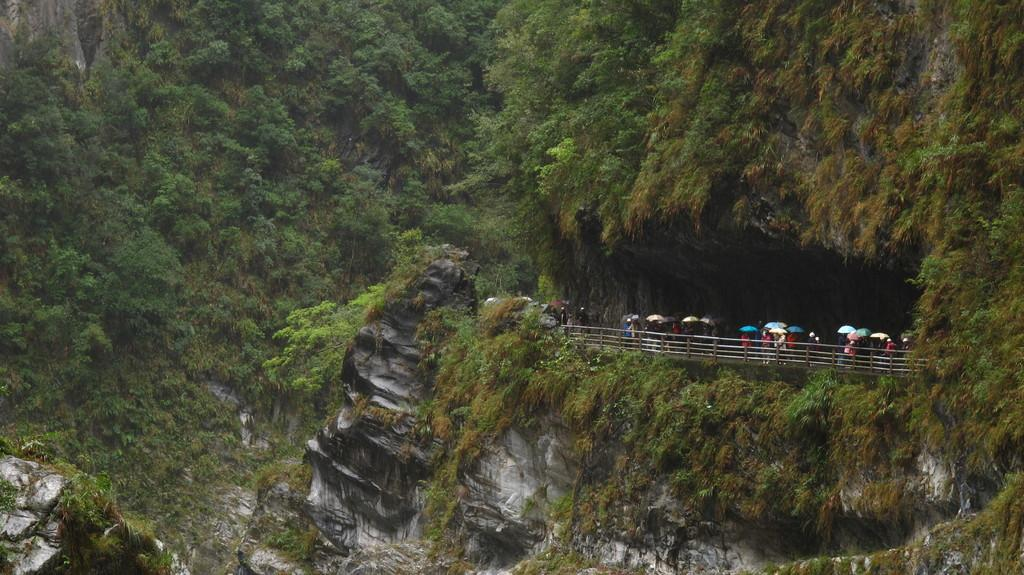What type of pathway is present in the image? There is a road in the image. Where is the road located? The road is under a cave. What can be seen in the background of the image? There are trees and grasslands visible in the background of the image. What type of art can be seen on the road in the image? There is no art present on the road in the image. What type of trade is happening on the road in the image? There is no trade happening on the road in the image. 